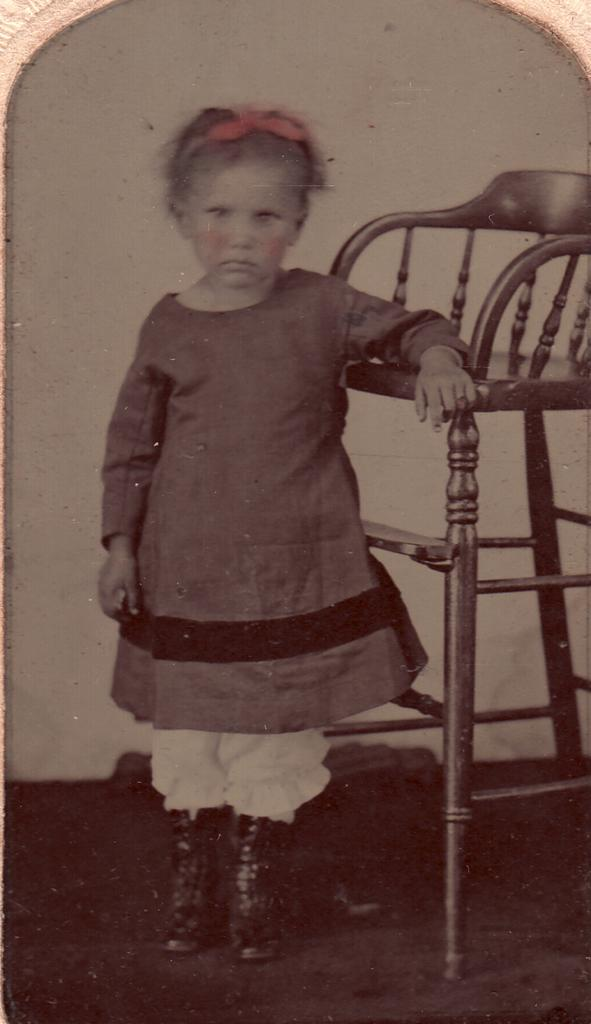What is the main subject in the image? There is a kid standing in the image. What object is on the floor in the image? There is a chair on the floor in the image. What can be seen in the background of the image? There is a wall visible in the background of the image. Is the kid talking to the tub in the image? There is no tub present in the image, so the kid cannot be talking to a tub. 